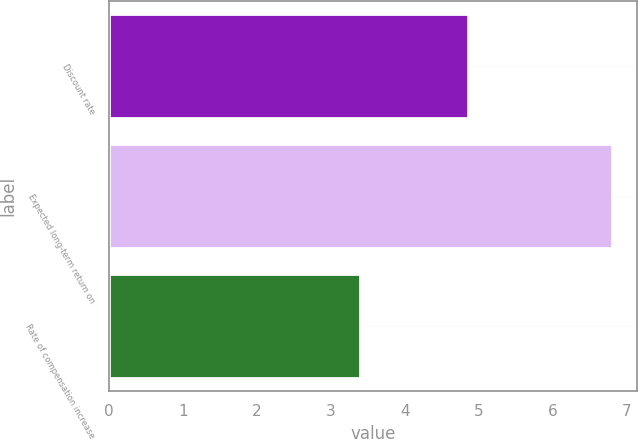<chart> <loc_0><loc_0><loc_500><loc_500><bar_chart><fcel>Discount rate<fcel>Expected long-term return on<fcel>Rate of compensation increase<nl><fcel>4.86<fcel>6.8<fcel>3.39<nl></chart> 